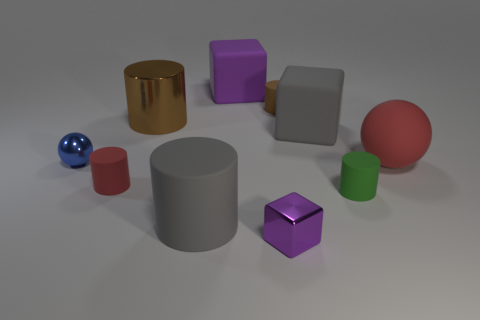The small object that is the same color as the big matte ball is what shape?
Your response must be concise. Cylinder. What material is the large gray thing in front of the gray thing right of the brown thing that is behind the metal cylinder?
Your response must be concise. Rubber. How many small objects are either rubber cylinders or green matte cylinders?
Give a very brief answer. 3. How many other objects are the same size as the purple matte object?
Give a very brief answer. 4. Is the shape of the large object in front of the small green rubber object the same as  the large purple rubber object?
Your response must be concise. No. The big metal thing that is the same shape as the tiny green object is what color?
Your response must be concise. Brown. Is there anything else that has the same shape as the large purple matte thing?
Your answer should be compact. Yes. Are there the same number of purple rubber blocks to the left of the big brown metallic cylinder and blue rubber balls?
Offer a very short reply. Yes. How many tiny things are to the right of the brown rubber object and behind the blue object?
Offer a terse response. 0. What size is the other red object that is the same shape as the large shiny object?
Ensure brevity in your answer.  Small. 